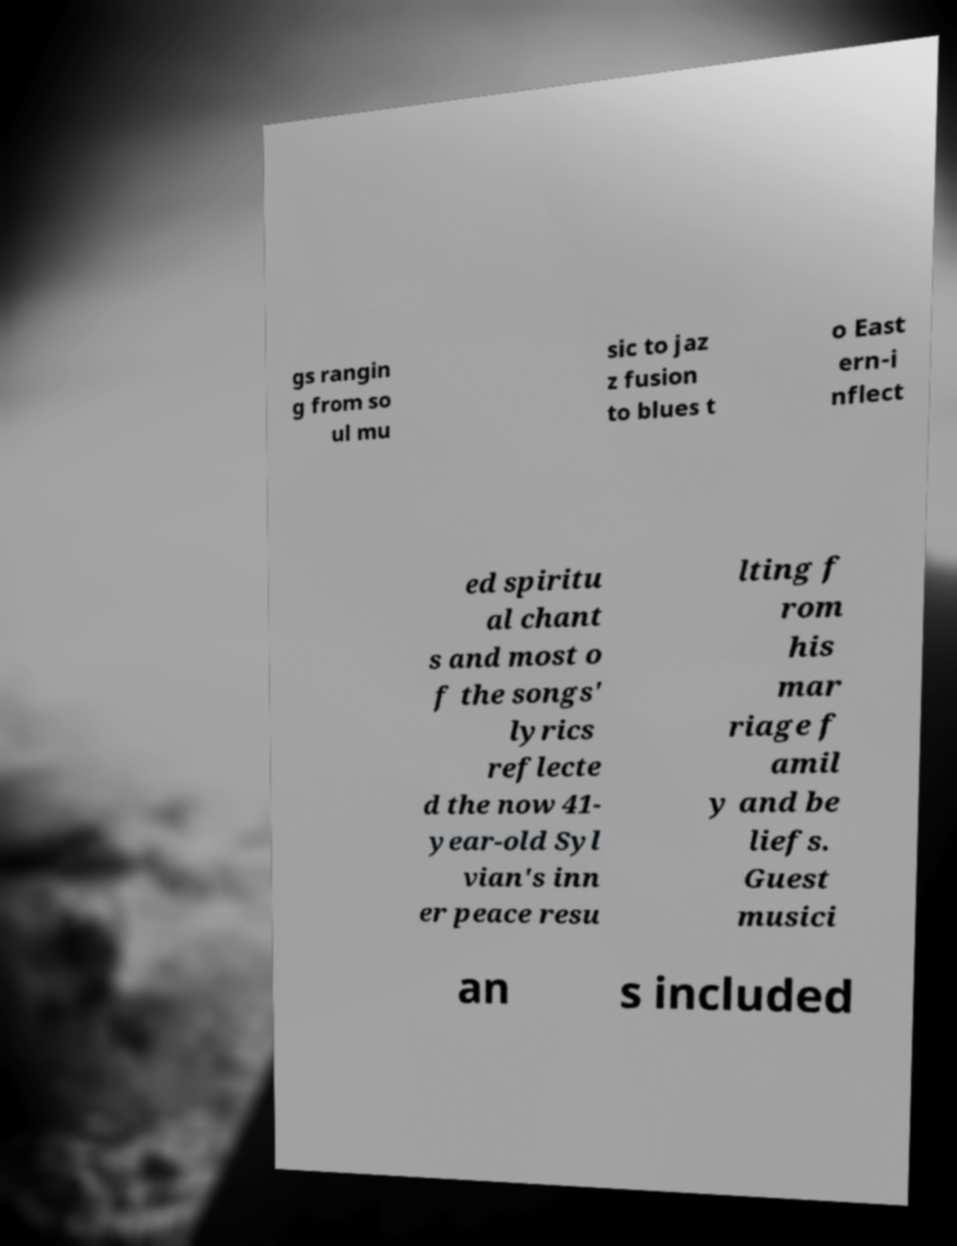What messages or text are displayed in this image? I need them in a readable, typed format. gs rangin g from so ul mu sic to jaz z fusion to blues t o East ern-i nflect ed spiritu al chant s and most o f the songs' lyrics reflecte d the now 41- year-old Syl vian's inn er peace resu lting f rom his mar riage f amil y and be liefs. Guest musici an s included 